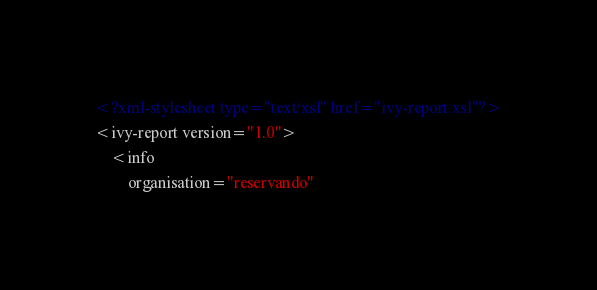Convert code to text. <code><loc_0><loc_0><loc_500><loc_500><_XML_><?xml-stylesheet type="text/xsl" href="ivy-report.xsl"?>
<ivy-report version="1.0">
	<info
		organisation="reservando"</code> 